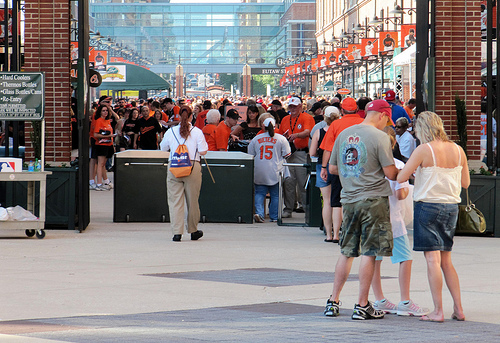<image>
Is there a man behind the girl? No. The man is not behind the girl. From this viewpoint, the man appears to be positioned elsewhere in the scene. Where is the girl in relation to the man? Is it behind the man? No. The girl is not behind the man. From this viewpoint, the girl appears to be positioned elsewhere in the scene. 